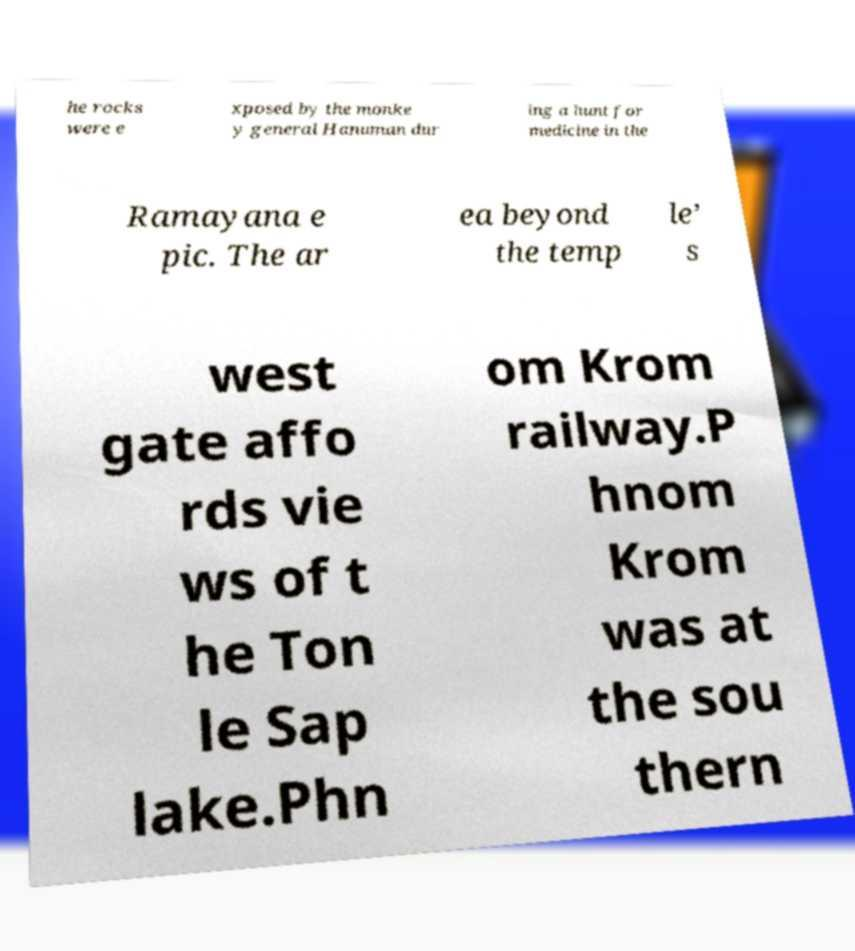Please identify and transcribe the text found in this image. he rocks were e xposed by the monke y general Hanuman dur ing a hunt for medicine in the Ramayana e pic. The ar ea beyond the temp le’ s west gate affo rds vie ws of t he Ton le Sap lake.Phn om Krom railway.P hnom Krom was at the sou thern 